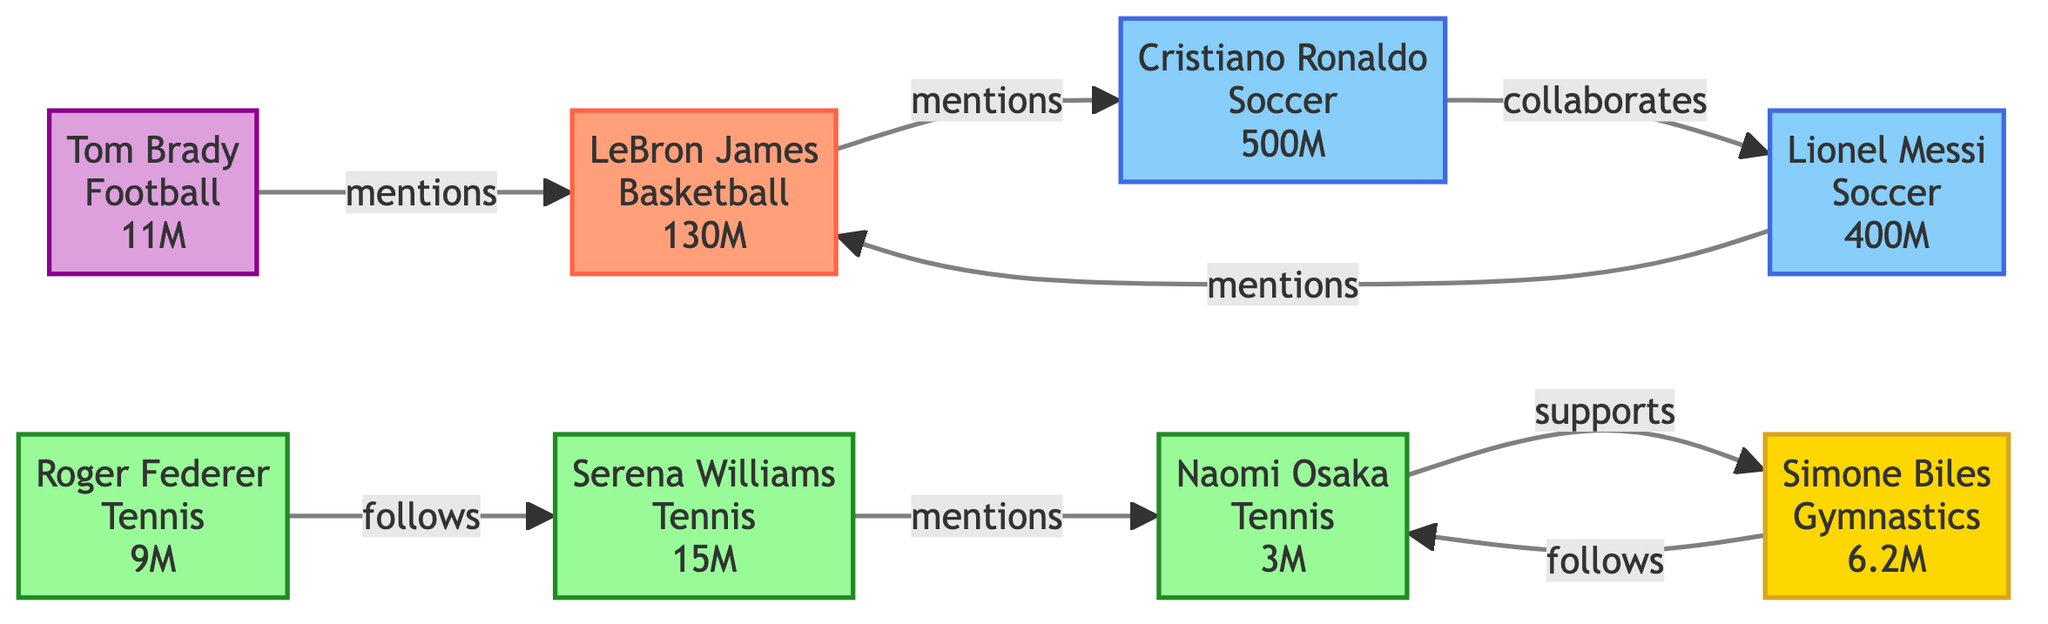What is the number of followers for Cristiano Ronaldo? The diagram states that Cristiano Ronaldo has 500 million followers, as indicated beside his name in the node.
Answer: 500 million How many athletes are mentioned in the diagram? The diagram displays a total of 8 nodes, each representing a different athlete, so there are 8 athletes in the diagram.
Answer: 8 Who collaborates with Cristiano Ronaldo? The diagram shows that Cristiano Ronaldo collaborates with Lionel Messi, indicated by a directed link labeled "collaborates" from Ronaldo to Messi.
Answer: Lionel Messi Which athlete follows Serena Williams? The diagram states that Roger Federer follows Serena Williams, indicated by a directed link from Federer to Williams labeled "follows".
Answer: Roger Federer What interaction does Naomi Osaka have with Simone Biles? According to the diagram, Naomi Osaka supports Simone Biles as indicated by the directed link from Osaka to Biles labeled "supports".
Answer: supports Which sport has the athlete with the most followers? By examining the follower counts, Cristiano Ronaldo from Soccer has the most followers at 500 million, which is more than any other athlete's follower count.
Answer: Soccer How many mentions does LeBron James receive? LeBron James is mentioned in interactions from Cristiano Ronaldo and Tom Brady, having 2 mentions indicated by the directed edges pointing towards him labeled "mentions".
Answer: 2 mentions What is the total number of interactions depicted in the diagram? The diagram lists a total of 7 interactions as represented by the directed links between the nodes, detailing them in their labels like "mentions", "follows", and "supports".
Answer: 7 How many athletes are involved in a "mentions" interaction? The diagram indicates that 4 athletes are involved in "mentions": LeBron James, Cristiano Ronaldo, Serena Williams, and Lionel Messi.
Answer: 4 athletes 